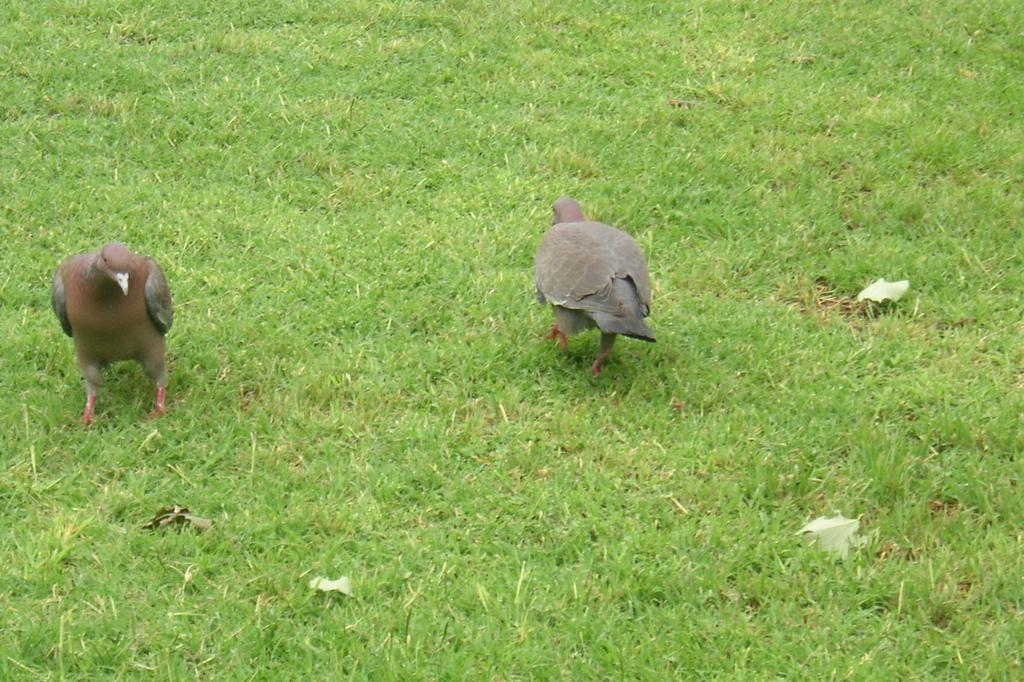Could you give a brief overview of what you see in this image? In this image I can see two birds on grass. This image is taken may be in a park. 